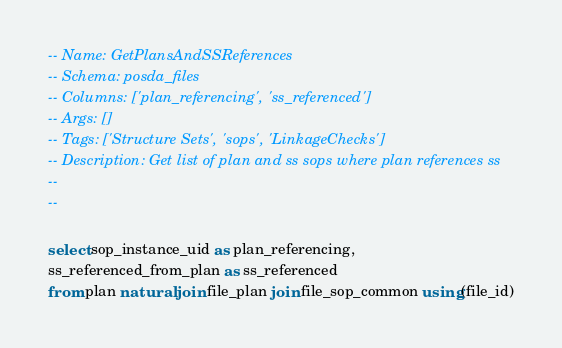Convert code to text. <code><loc_0><loc_0><loc_500><loc_500><_SQL_>-- Name: GetPlansAndSSReferences
-- Schema: posda_files
-- Columns: ['plan_referencing', 'ss_referenced']
-- Args: []
-- Tags: ['Structure Sets', 'sops', 'LinkageChecks']
-- Description: Get list of plan and ss sops where plan references ss
-- 
-- 

select sop_instance_uid as plan_referencing,
ss_referenced_from_plan as ss_referenced
from plan natural join file_plan join file_sop_common using(file_id)</code> 